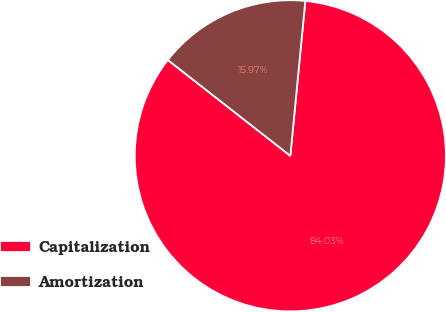Convert chart to OTSL. <chart><loc_0><loc_0><loc_500><loc_500><pie_chart><fcel>Capitalization<fcel>Amortization<nl><fcel>84.03%<fcel>15.97%<nl></chart> 